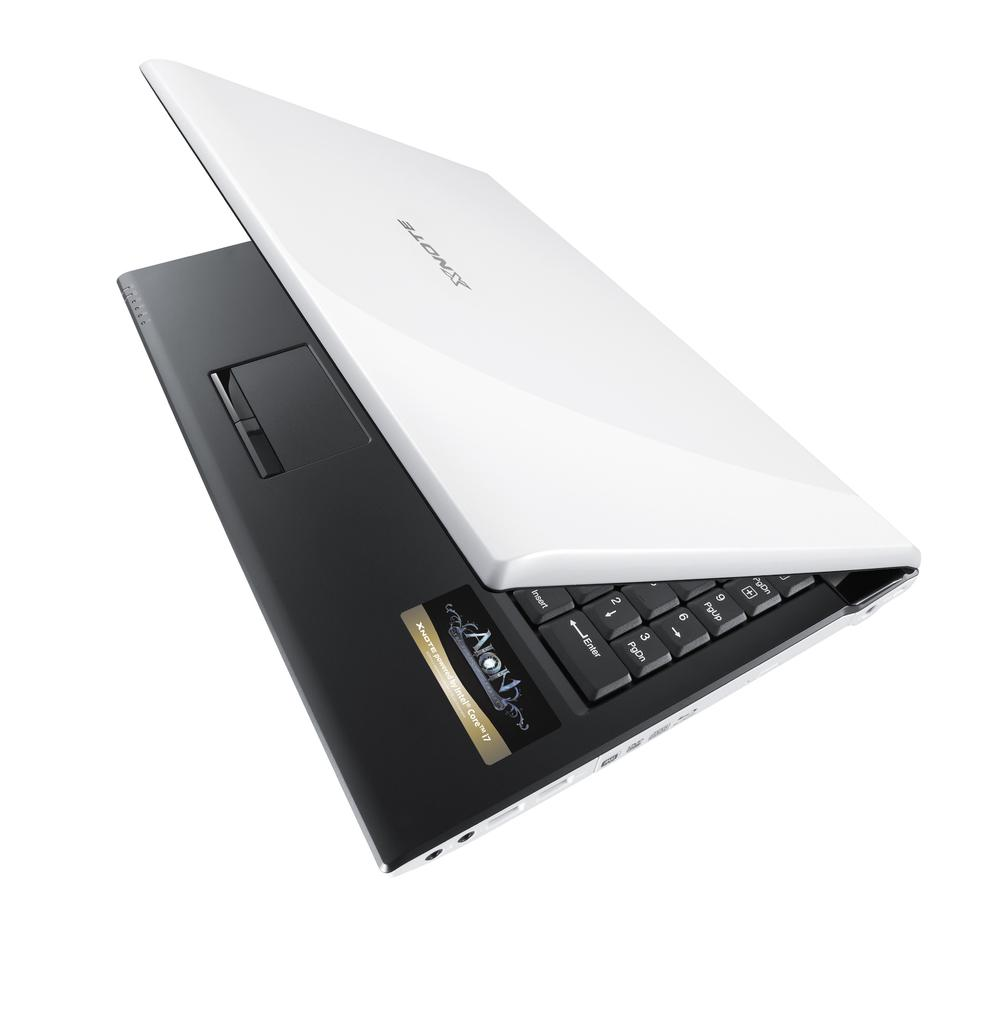<image>
Write a terse but informative summary of the picture. A laptop computer is halfway open and has the brand name AION on it and it powered by an Intel core processor. 